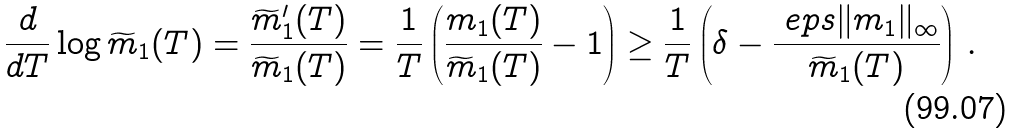<formula> <loc_0><loc_0><loc_500><loc_500>\frac { d } { d T } \log \widetilde { m } _ { 1 } ( T ) = \frac { \widetilde { m } ^ { \prime } _ { 1 } ( T ) } { \widetilde { m } _ { 1 } ( T ) } = \frac { 1 } { T } \left ( \frac { m _ { 1 } ( T ) } { \widetilde { m } _ { 1 } ( T ) } - 1 \right ) \geq \frac { 1 } { T } \left ( \delta - \frac { \ e p s \| m _ { 1 } \| _ { \infty } } { \widetilde { m } _ { 1 } ( T ) } \right ) \, .</formula> 